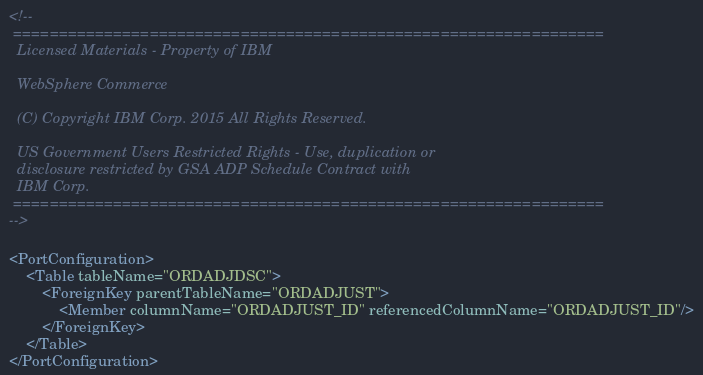Convert code to text. <code><loc_0><loc_0><loc_500><loc_500><_XML_><!--
 =================================================================
  Licensed Materials - Property of IBM

  WebSphere Commerce

  (C) Copyright IBM Corp. 2015 All Rights Reserved.

  US Government Users Restricted Rights - Use, duplication or
  disclosure restricted by GSA ADP Schedule Contract with
  IBM Corp.
 =================================================================
-->

<PortConfiguration>
	<Table tableName="ORDADJDSC">
		<ForeignKey parentTableName="ORDADJUST">
			<Member columnName="ORDADJUST_ID" referencedColumnName="ORDADJUST_ID"/>
		</ForeignKey>
	</Table>
</PortConfiguration></code> 